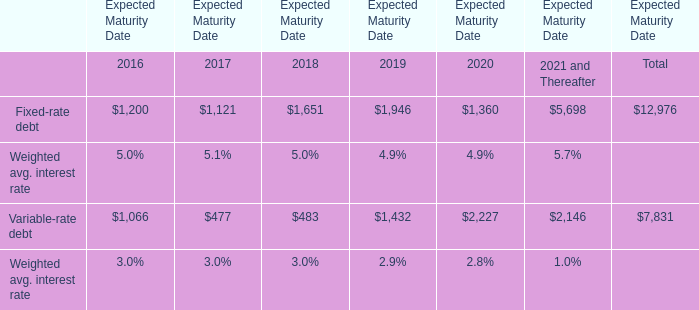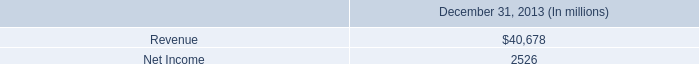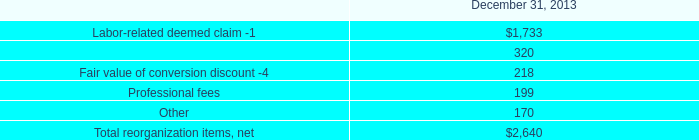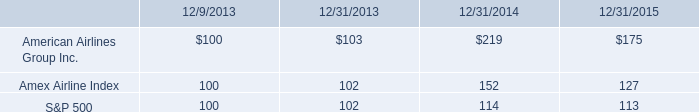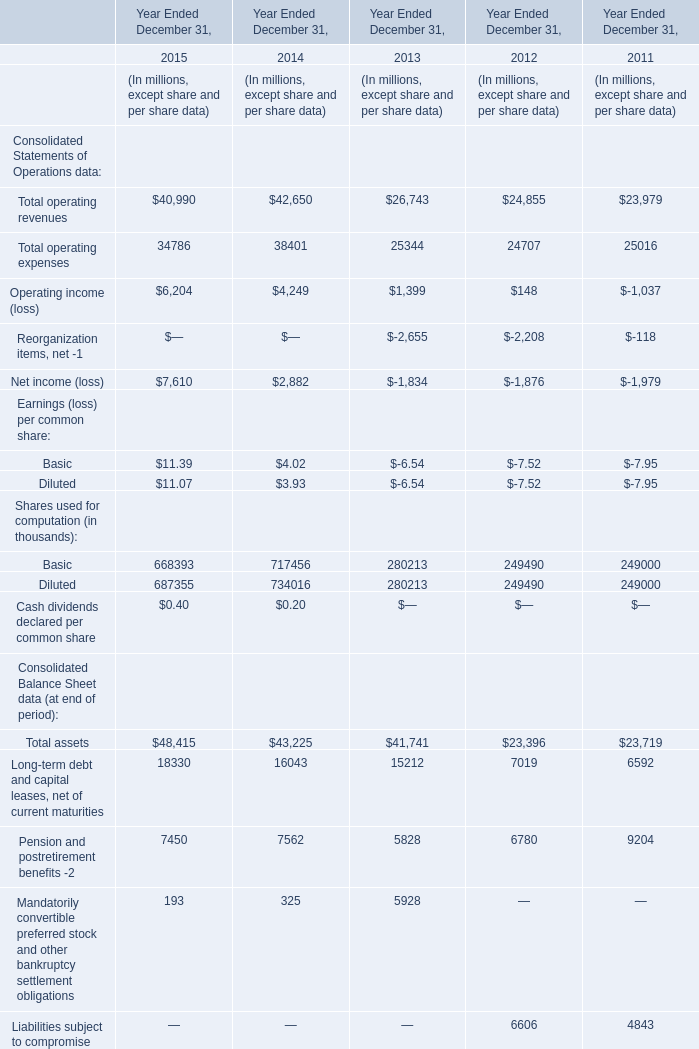what was the rate of growth or decrease from 2013 to 2014 on the amex airline index 
Computations: ((152 - 102) / 102)
Answer: 0.4902. 